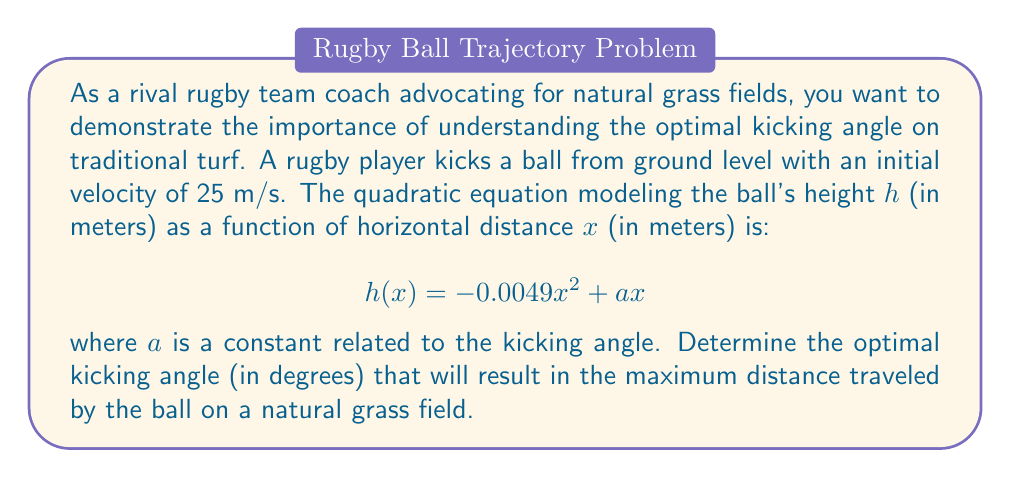Give your solution to this math problem. To solve this problem, we'll follow these steps:

1) The quadratic equation given is in the form $h(x) = -bx^2 + ax$, where $b = 0.0049$ and $a$ is unknown.

2) For a projectile motion, the maximum horizontal distance is achieved when the initial angle is 45°. At this angle, $a = \tan(45°)$.

3) $\tan(45°) = 1$, so when the angle is optimal, $a = 1$.

4) To verify this, we can use the quadratic formula to find the roots of the equation:

   $$x = \frac{-a \pm \sqrt{a^2 + 4bh}}{-2b}$$

   where $h = 0$ (the ball returns to ground level).

5) Substituting the values:

   $$x = \frac{-a \pm \sqrt{a^2}}{2(0.0049)} = \frac{a}{0.0098}$$

6) The maximum value of $x$ occurs when $a = 1$, confirming that 45° is indeed the optimal angle.

7) To convert the angle from radians to degrees:

   $$45° = \arctan(1) \approx 0.7854 \text{ radians}$$

Therefore, the optimal kicking angle is 45°.
Answer: The optimal kicking angle for maximum distance on a natural grass field is 45°. 